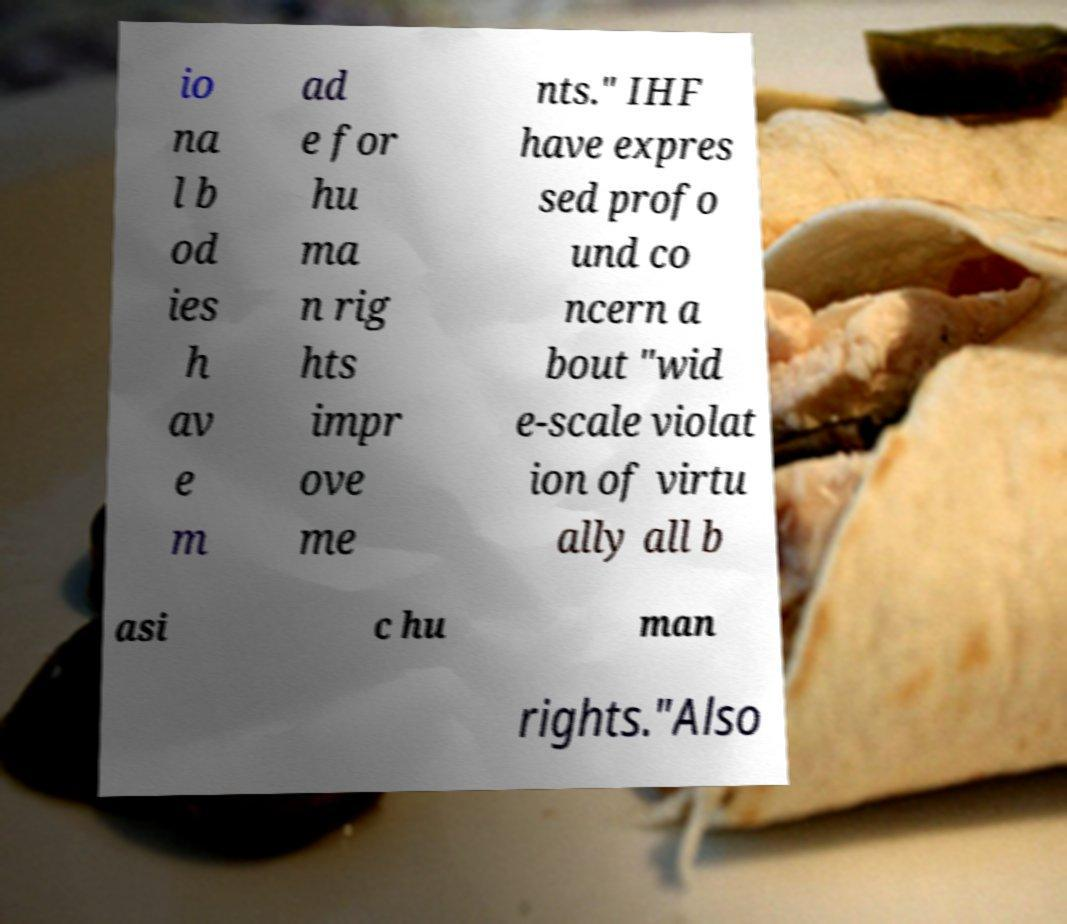Could you assist in decoding the text presented in this image and type it out clearly? io na l b od ies h av e m ad e for hu ma n rig hts impr ove me nts." IHF have expres sed profo und co ncern a bout "wid e-scale violat ion of virtu ally all b asi c hu man rights."Also 